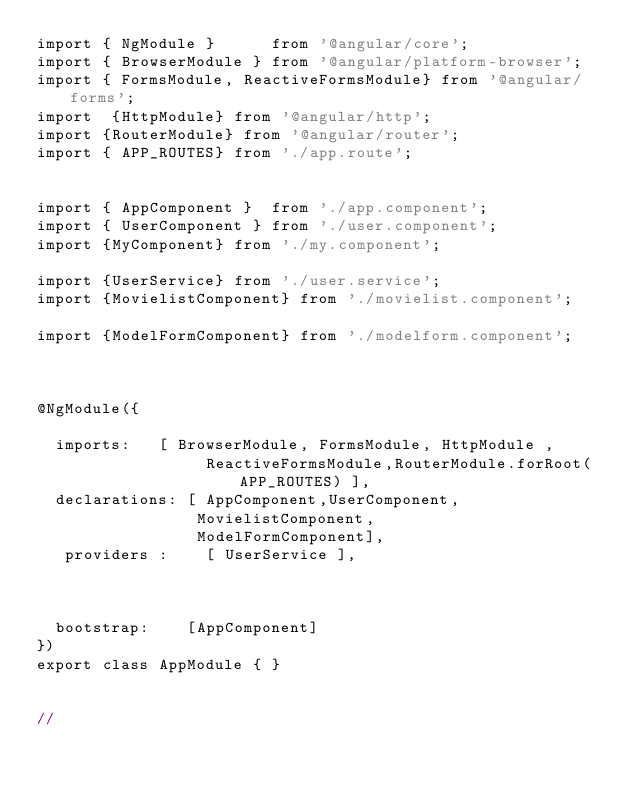Convert code to text. <code><loc_0><loc_0><loc_500><loc_500><_TypeScript_>import { NgModule }      from '@angular/core';
import { BrowserModule } from '@angular/platform-browser';
import { FormsModule, ReactiveFormsModule} from '@angular/forms';
import  {HttpModule} from '@angular/http';
import {RouterModule} from '@angular/router';
import { APP_ROUTES} from './app.route';


import { AppComponent }  from './app.component';
import { UserComponent } from './user.component';
import {MyComponent} from './my.component';

import {UserService} from './user.service';
import {MovielistComponent} from './movielist.component';

import {ModelFormComponent} from './modelform.component';



@NgModule({

  imports:   [ BrowserModule, FormsModule, HttpModule ,
                  ReactiveFormsModule,RouterModule.forRoot(APP_ROUTES) ],
  declarations: [ AppComponent,UserComponent,
                 MovielistComponent,
                 ModelFormComponent],
   providers :    [ UserService ],
  
  	     
      
  bootstrap:    [AppComponent]
})
export class AppModule { }


// </code> 